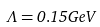<formula> <loc_0><loc_0><loc_500><loc_500>\Lambda = 0 . 1 5 G e V</formula> 